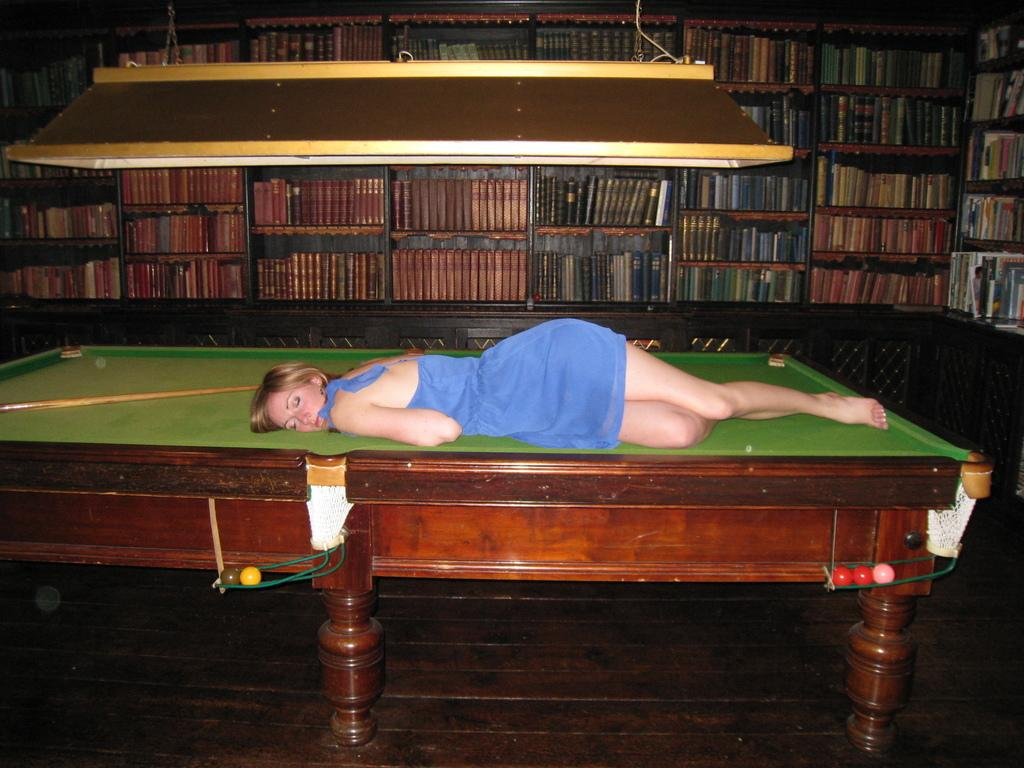What is the woman doing in the image? The woman is lying on a tennis table. What can be seen in the background of the image? There is a shelf with full of boxes in the background. What type of pies is the woman wearing on her head in the image? There are no pies present in the image, nor is the woman wearing any on her head. 